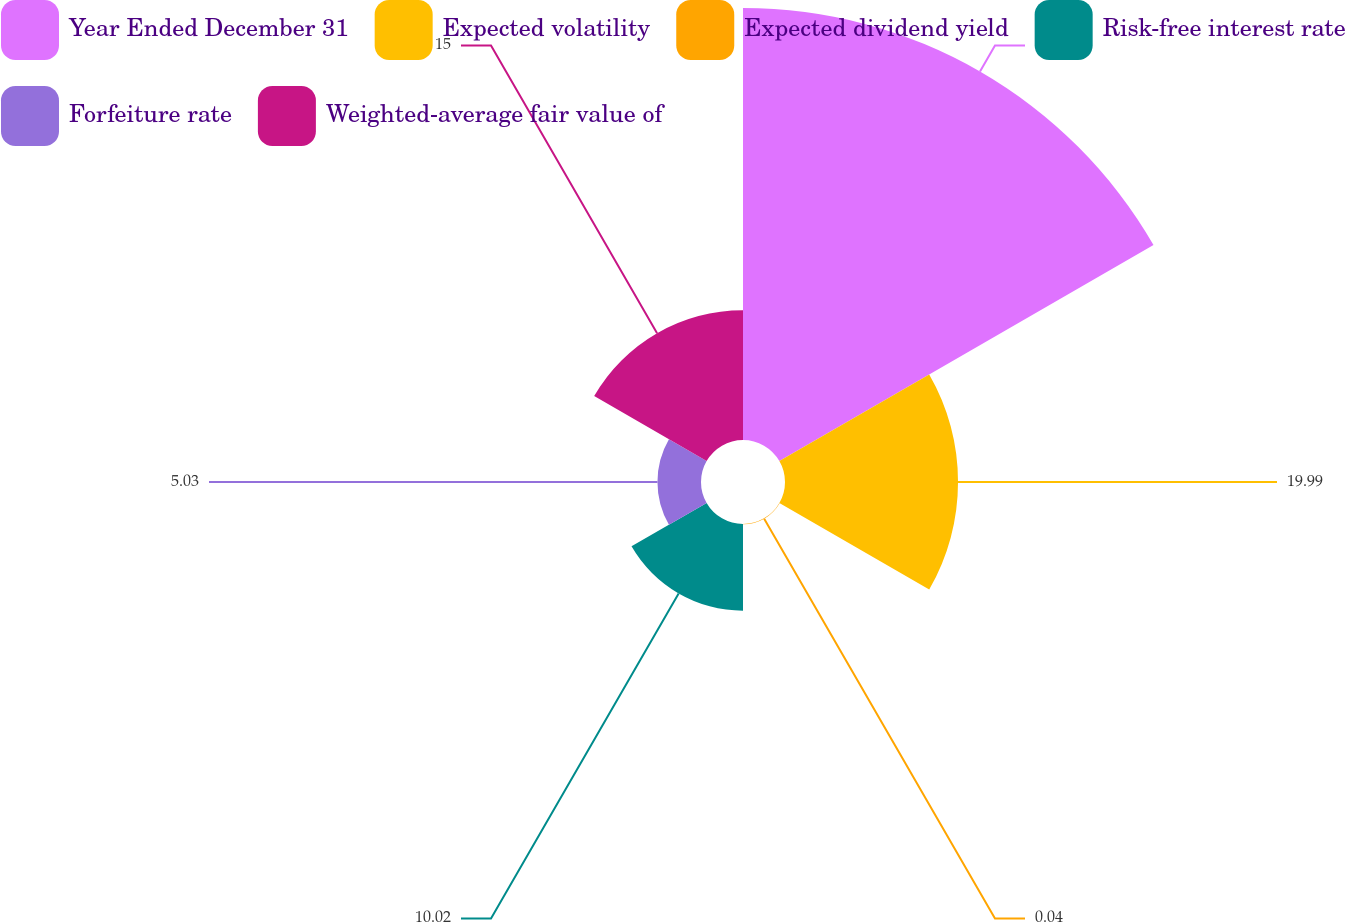<chart> <loc_0><loc_0><loc_500><loc_500><pie_chart><fcel>Year Ended December 31<fcel>Expected volatility<fcel>Expected dividend yield<fcel>Risk-free interest rate<fcel>Forfeiture rate<fcel>Weighted-average fair value of<nl><fcel>49.91%<fcel>19.99%<fcel>0.04%<fcel>10.02%<fcel>5.03%<fcel>15.0%<nl></chart> 